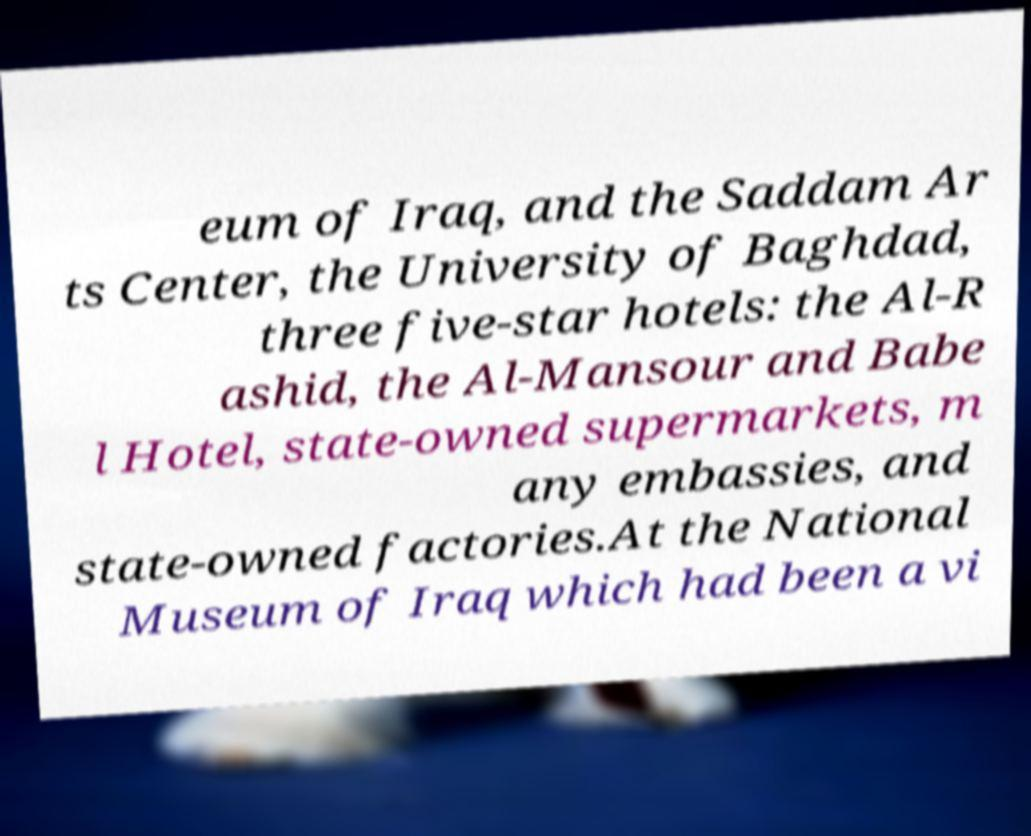For documentation purposes, I need the text within this image transcribed. Could you provide that? eum of Iraq, and the Saddam Ar ts Center, the University of Baghdad, three five-star hotels: the Al-R ashid, the Al-Mansour and Babe l Hotel, state-owned supermarkets, m any embassies, and state-owned factories.At the National Museum of Iraq which had been a vi 